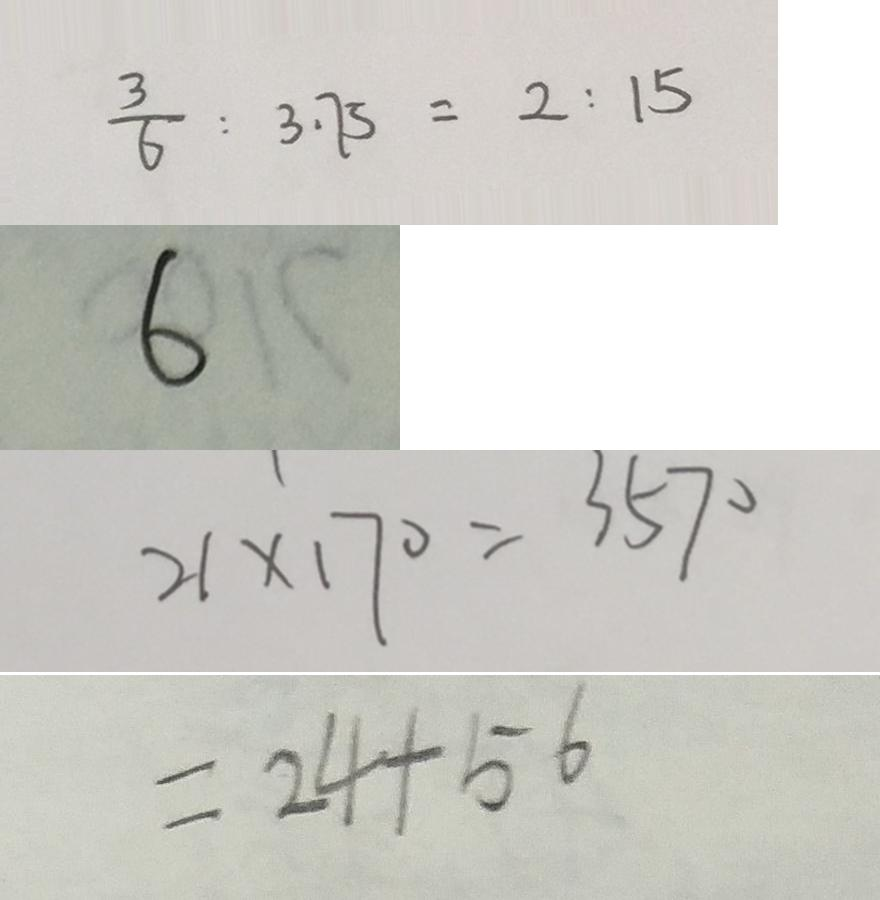<formula> <loc_0><loc_0><loc_500><loc_500>\frac { 3 } { 6 } : 3 . 7 5 = 2 : 1 5 
 6 
 2 1 \times 1 7 0 = 3 5 7 0 
 = 2 4 + 5 6</formula> 